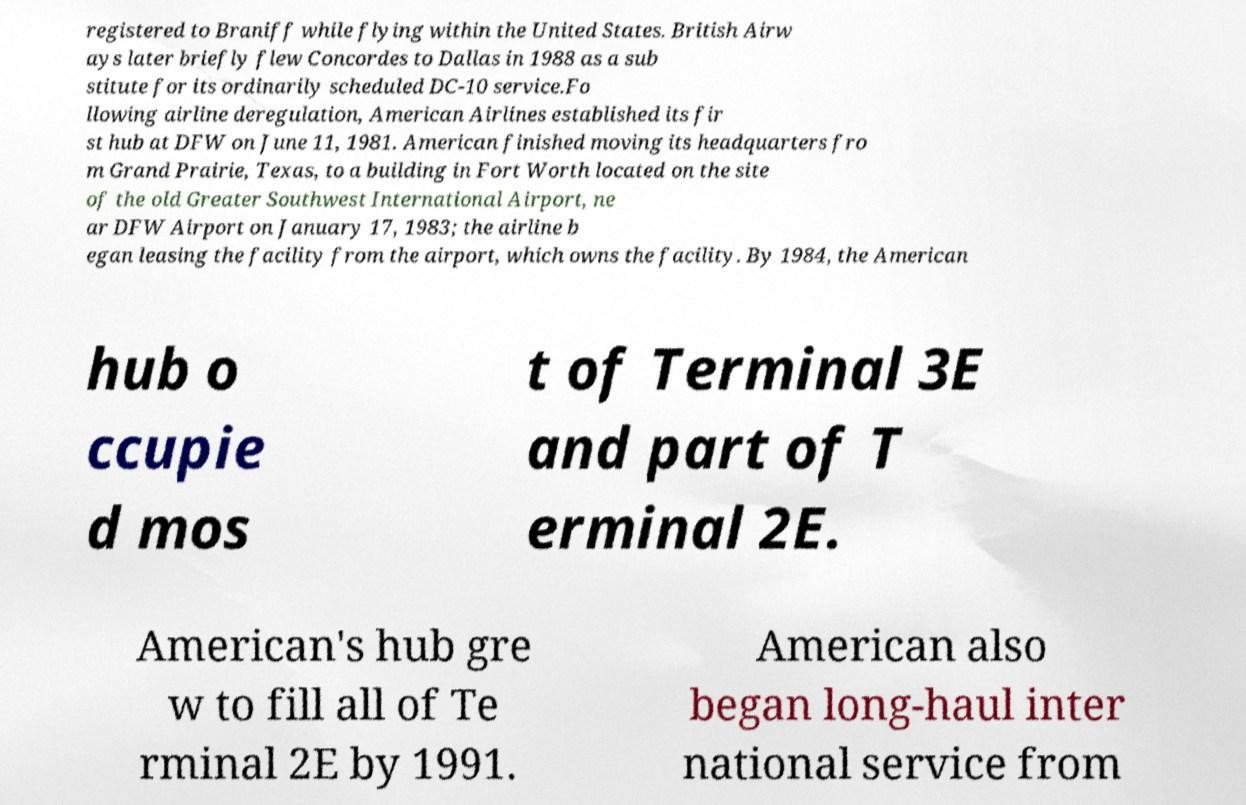Can you accurately transcribe the text from the provided image for me? registered to Braniff while flying within the United States. British Airw ays later briefly flew Concordes to Dallas in 1988 as a sub stitute for its ordinarily scheduled DC-10 service.Fo llowing airline deregulation, American Airlines established its fir st hub at DFW on June 11, 1981. American finished moving its headquarters fro m Grand Prairie, Texas, to a building in Fort Worth located on the site of the old Greater Southwest International Airport, ne ar DFW Airport on January 17, 1983; the airline b egan leasing the facility from the airport, which owns the facility. By 1984, the American hub o ccupie d mos t of Terminal 3E and part of T erminal 2E. American's hub gre w to fill all of Te rminal 2E by 1991. American also began long-haul inter national service from 